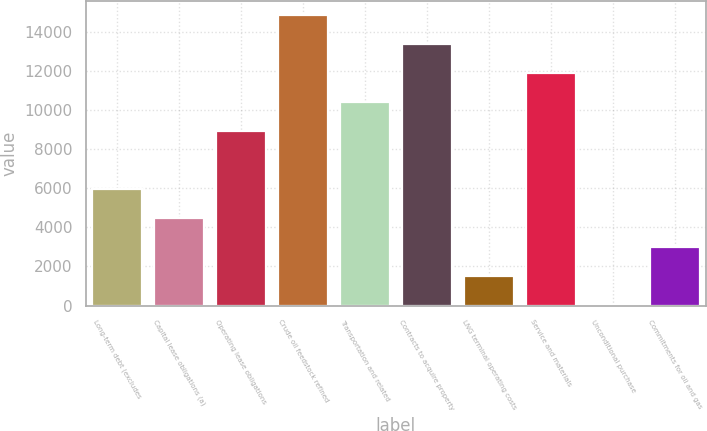Convert chart. <chart><loc_0><loc_0><loc_500><loc_500><bar_chart><fcel>Long-term debt (excludes<fcel>Capital lease obligations (a)<fcel>Operating lease obligations<fcel>Crude oil feedstock refined<fcel>Transportation and related<fcel>Contracts to acquire property<fcel>LNG terminal operating costs<fcel>Service and materials<fcel>Unconditional purchase<fcel>Commitments for oil and gas<nl><fcel>5938.8<fcel>4456.1<fcel>8904.2<fcel>14835<fcel>10386.9<fcel>13352.3<fcel>1490.7<fcel>11869.6<fcel>8<fcel>2973.4<nl></chart> 